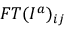Convert formula to latex. <formula><loc_0><loc_0><loc_500><loc_500>F T ( I ^ { a } ) _ { i j }</formula> 